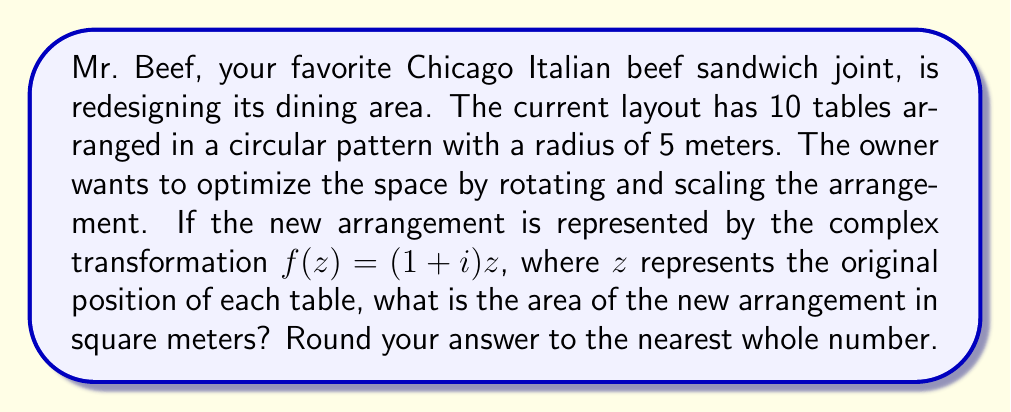Teach me how to tackle this problem. Let's approach this step-by-step:

1) The original arrangement is circular with a radius of 5 meters. The area of this circle is:
   
   $$A_1 = \pi r^2 = \pi (5^2) = 25\pi \approx 78.54 \text{ m}^2$$

2) The complex transformation $f(z) = (1+i)z$ can be broken down into two parts:
   - Scaling by $|1+i| = \sqrt{1^2 + 1^2} = \sqrt{2}$
   - Rotation by $\arg(1+i) = 45°$ counterclockwise

3) The scaling factor is $\sqrt{2}$. This means all distances from the center will be multiplied by $\sqrt{2}$.

4) The new radius will be:
   
   $$r_{new} = 5\sqrt{2} \text{ meters}$$

5) The area of the new arrangement will be:
   
   $$A_2 = \pi (r_{new})^2 = \pi (5\sqrt{2})^2 = 50\pi \text{ m}^2$$

6) To get the numerical value:
   
   $$A_2 = 50\pi \approx 157.08 \text{ m}^2$$

7) Rounding to the nearest whole number:
   
   $$A_2 \approx 157 \text{ m}^2$$
Answer: 157 square meters 